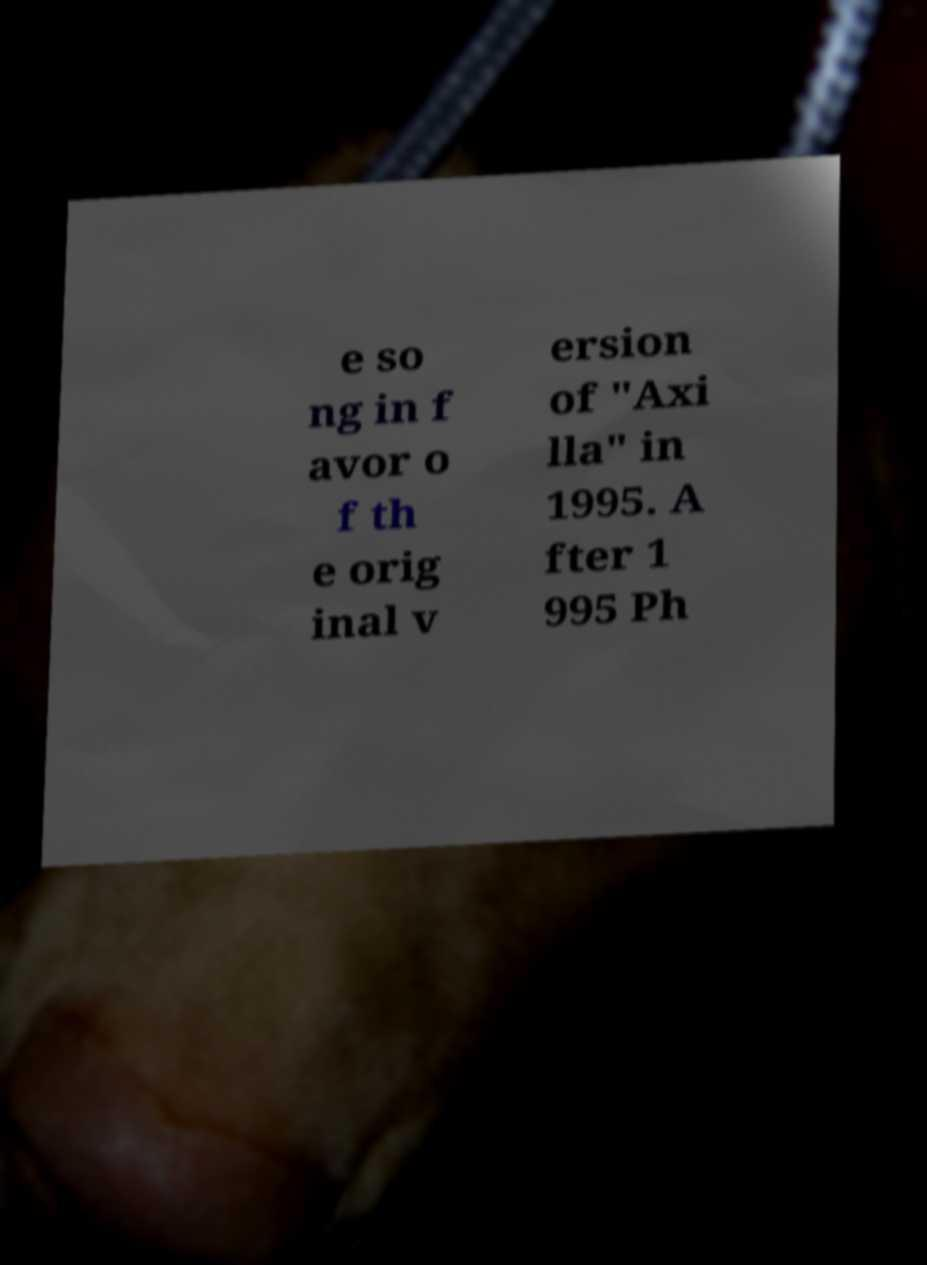Could you assist in decoding the text presented in this image and type it out clearly? e so ng in f avor o f th e orig inal v ersion of "Axi lla" in 1995. A fter 1 995 Ph 